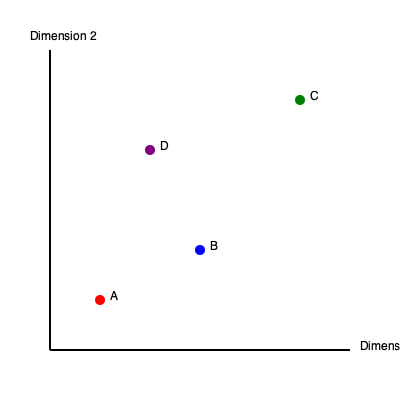In the multidimensional scaling (MDS) plot above, which two objects are most dissimilar based on their positions? Explain your reasoning using the principles of MDS interpretation. To interpret a multidimensional scaling (MDS) plot and determine which objects are most dissimilar, we need to follow these steps:

1. Understand the principle of MDS:
   - In MDS, objects that are more similar are positioned closer together, while dissimilar objects are placed farther apart.

2. Examine the dimensions:
   - The plot shows two dimensions, representing the primary factors of variation among the objects.

3. Assess relative positions:
   - Object A is in the lower-left quadrant
   - Object B is in the middle-right area
   - Object C is in the upper-right quadrant
   - Object D is near the center

4. Calculate distances:
   - While exact calculations aren't possible without precise coordinates, we can visually estimate relative distances.
   - The greatest distance appears to be between objects A and C.

5. Consider both dimensions:
   - A and C are far apart on both Dimension 1 and Dimension 2, indicating high dissimilarity in multiple aspects.

6. Compare with other pairs:
   - Other pairs (e.g., A-B, B-C, A-D) have smaller distances between them compared to A-C.

Therefore, based on the principles of MDS interpretation, objects A and C are positioned farthest apart in the two-dimensional space, indicating they are the most dissimilar among the plotted objects.
Answer: Objects A and C are most dissimilar. 